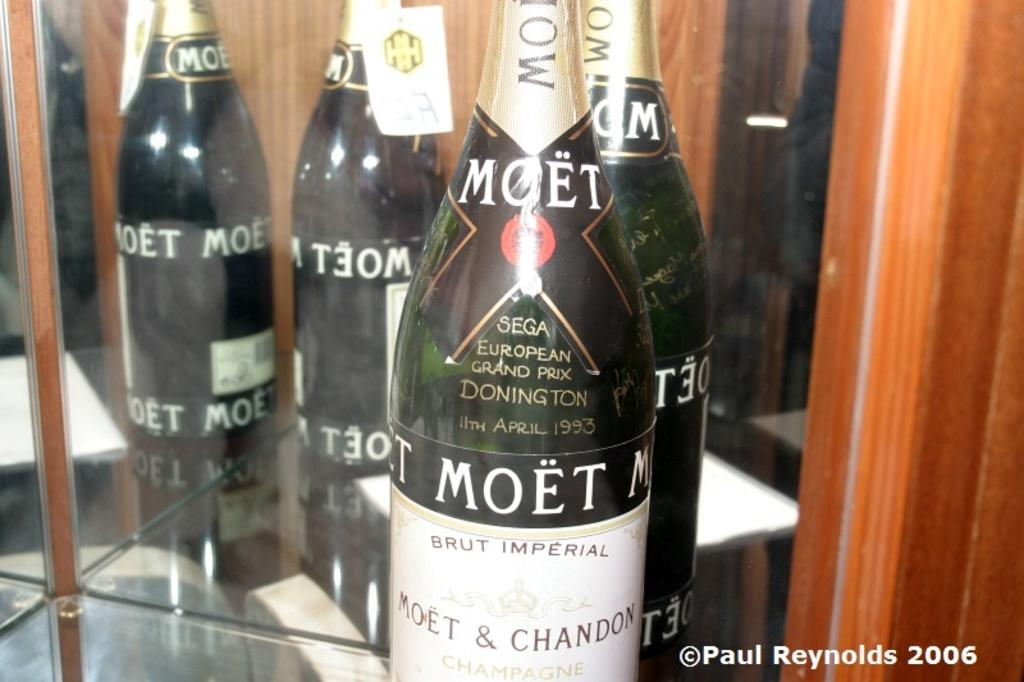Provide a one-sentence caption for the provided image. a bottle that has the word moet on it. 